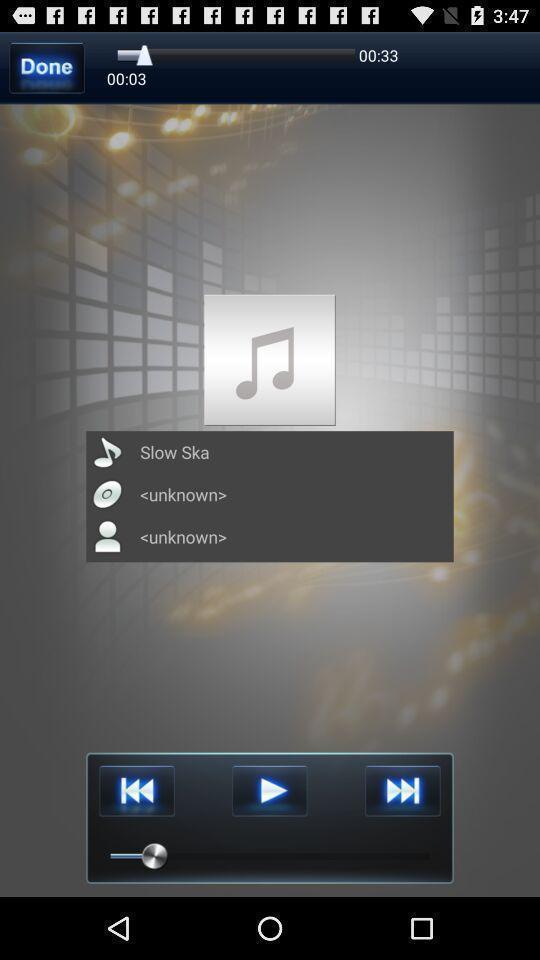Provide a detailed account of this screenshot. Screen page displaying various options in music application. 